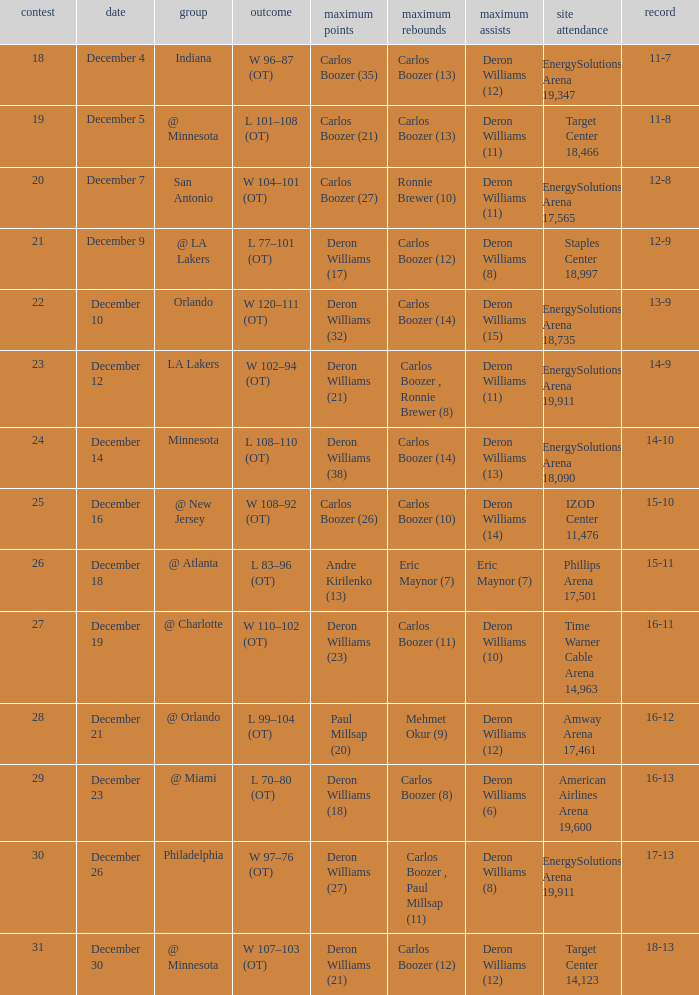How many different high rebound results are there for the game number 26? 1.0. 